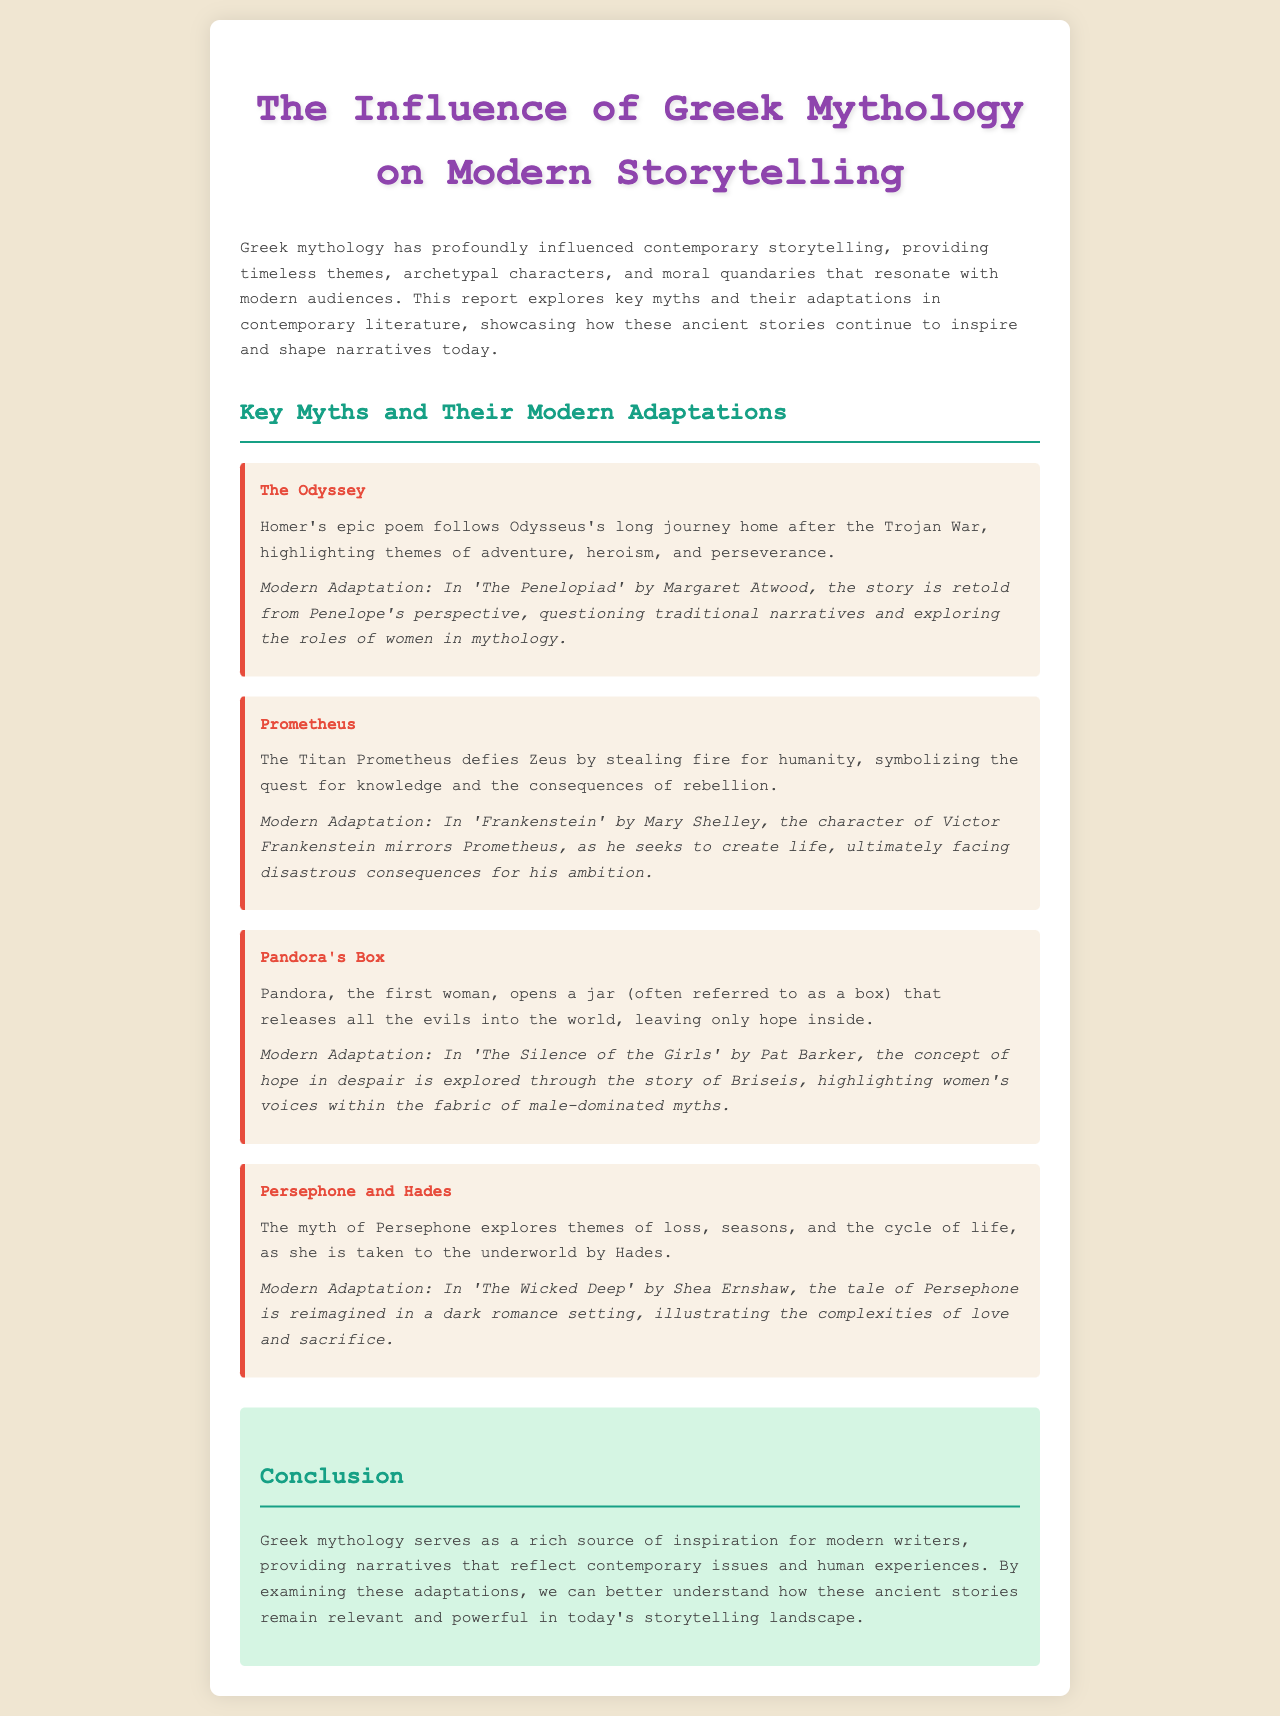What is the title of the report? The title of the report appears at the top of the document, which is "The Influence of Greek Mythology on Modern Storytelling."
Answer: The Influence of Greek Mythology on Modern Storytelling Who retold 'The Odyssey' from Penelope's perspective? The document identifies Margaret Atwood as the author who retells 'The Odyssey'.
Answer: Margaret Atwood What does Pandora release when she opens the jar? The document specifies that when Pandora opens the jar, all the evils are released into the world.
Answer: All the evils Which character in modern adaptations mirrors Prometheus? The document states that Victor Frankenstein in 'Frankenstein' mirrors Prometheus through his quest for knowledge.
Answer: Victor Frankenstein What theme is explored in the myth of Persephone and Hades? The document indicates that the myth explores themes of loss, seasons, and the cycle of life.
Answer: Loss, seasons, and the cycle of life How is 'The Silence of the Girls' related to Pandora's story? The adaptation allows for the exploration of hope in despair through the character of Briseis, linking it to Pandora's myth.
Answer: Women's voices in despair In what way does Greek mythology influence contemporary storytelling according to the document? The document mentions that Greek mythology provides timeless themes, archetypal characters, and moral quandaries which resonate today.
Answer: Timeless themes and archetypal characters What type of literature does 'The Penelopiad' represent? The document classifies 'The Penelopiad' as a modern adaptation of an ancient Greek myth.
Answer: Modern adaptation 